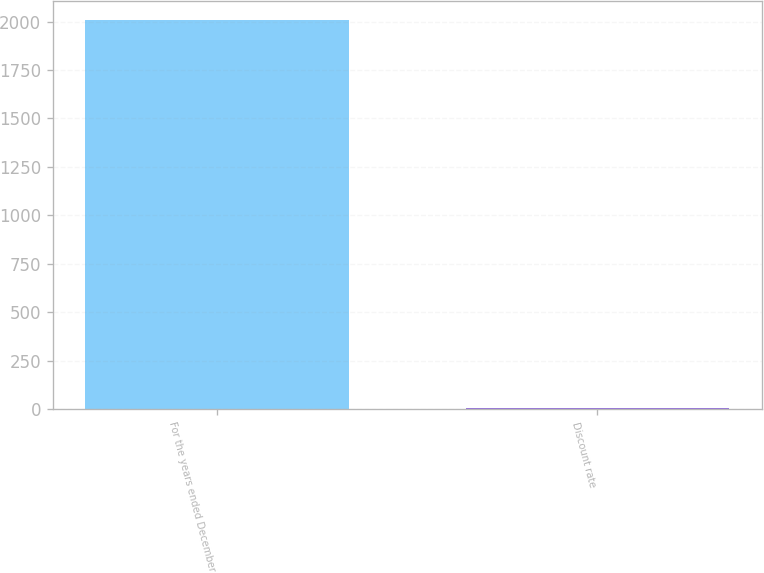Convert chart to OTSL. <chart><loc_0><loc_0><loc_500><loc_500><bar_chart><fcel>For the years ended December<fcel>Discount rate<nl><fcel>2006<fcel>5.4<nl></chart> 